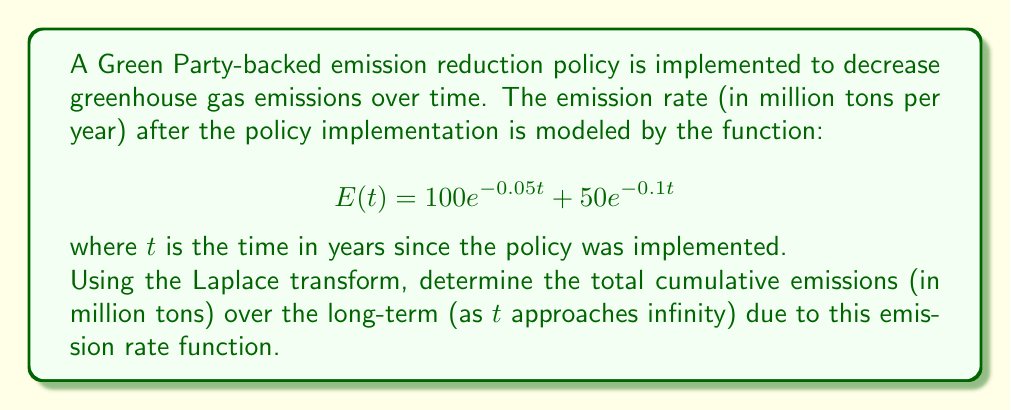What is the answer to this math problem? To solve this problem, we'll use the following steps:

1) First, we need to find the Laplace transform of $E(t)$.
2) Then, we'll use the final value theorem to find the long-term cumulative emissions.

Step 1: Finding the Laplace transform of $E(t)$

The Laplace transform of $E(t)$ is:

$$\mathcal{L}\{E(t)\} = \mathcal{L}\{100e^{-0.05t} + 50e^{-0.1t}\}$$

Using the linearity property and the Laplace transform of exponential functions:

$$\mathcal{L}\{E(t)\} = 100\cdot\frac{1}{s+0.05} + 50\cdot\frac{1}{s+0.1}$$

Step 2: Finding the cumulative emissions

The cumulative emissions function $C(t)$ is the integral of $E(t)$:

$$C(t) = \int_0^t E(\tau) d\tau$$

In the Laplace domain, integration becomes division by $s$:

$$\mathcal{L}\{C(t)\} = \frac{1}{s}\mathcal{L}\{E(t)\} = \frac{100}{s(s+0.05)} + \frac{50}{s(s+0.1)}$$

Step 3: Applying the final value theorem

The final value theorem states that for a function $f(t)$ with Laplace transform $F(s)$:

$$\lim_{t\to\infty} f(t) = \lim_{s\to 0} sF(s)$$

Applying this to our cumulative emissions function:

$$\lim_{t\to\infty} C(t) = \lim_{s\to 0} s\left(\frac{100}{s(s+0.05)} + \frac{50}{s(s+0.1)}\right)$$

$$= \lim_{s\to 0} \left(\frac{100}{s+0.05} + \frac{50}{s+0.1}\right)$$

$$= \frac{100}{0.05} + \frac{50}{0.1} = 2000 + 500 = 2500$$

Therefore, the total cumulative emissions over the long-term are 2500 million tons.
Answer: 2500 million tons 